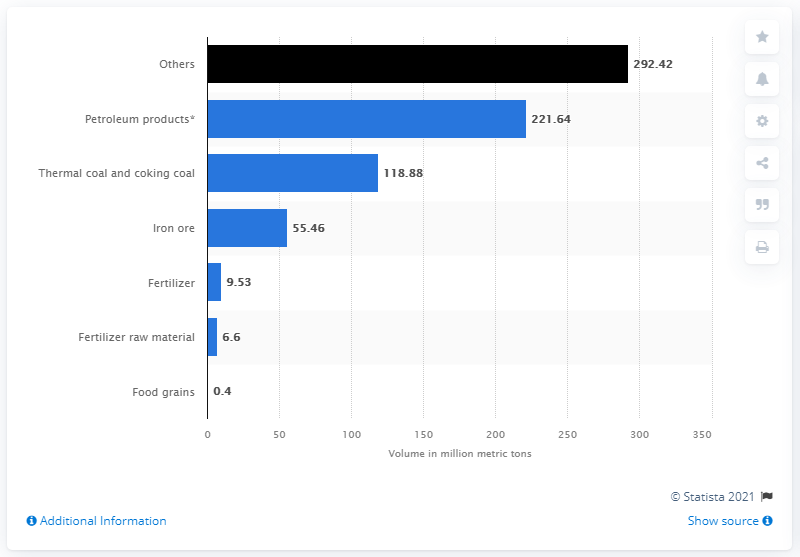Highlight a few significant elements in this photo. At the end of fiscal year 2020, the total amount of petroleum products traffic handled at major ports across India was 221.64 million metric tons. 